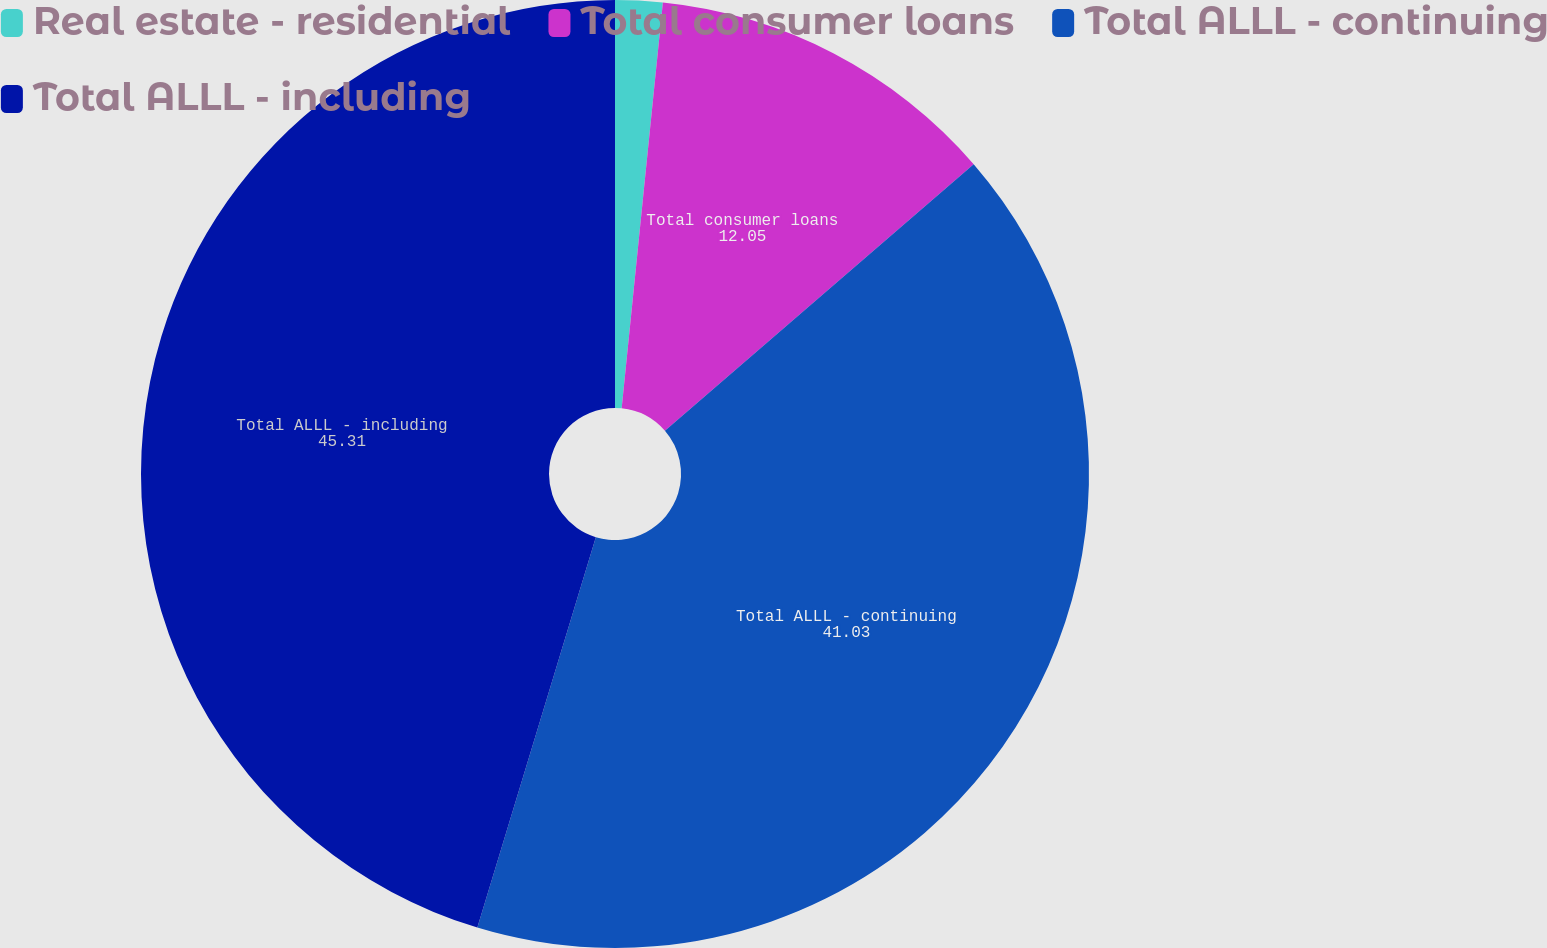<chart> <loc_0><loc_0><loc_500><loc_500><pie_chart><fcel>Real estate - residential<fcel>Total consumer loans<fcel>Total ALLL - continuing<fcel>Total ALLL - including<nl><fcel>1.61%<fcel>12.05%<fcel>41.03%<fcel>45.31%<nl></chart> 